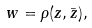Convert formula to latex. <formula><loc_0><loc_0><loc_500><loc_500>w = \rho ( z , \bar { z } ) ,</formula> 